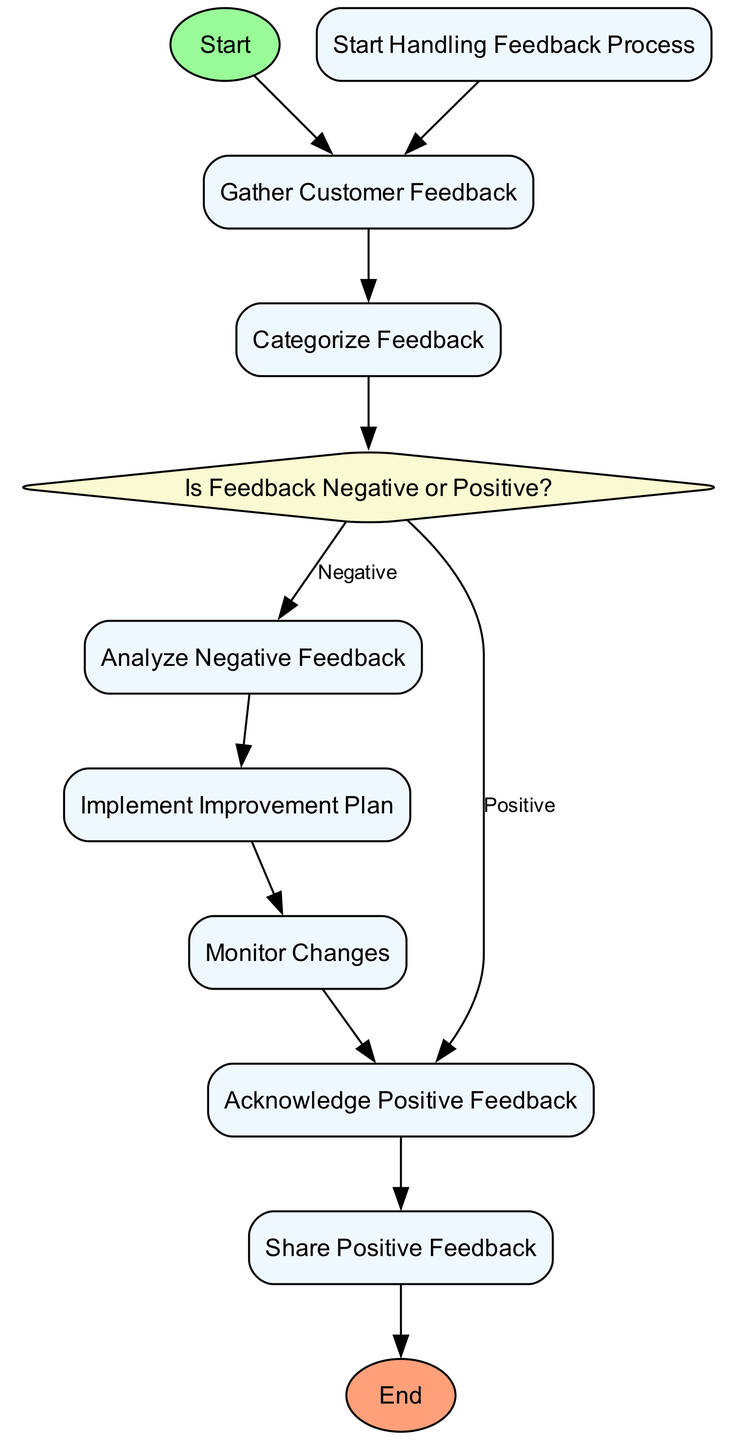What's the first action in the diagram? The first action after the start node is "Gather Customer Feedback", as it directly follows the start and represents the first step in the process.
Answer: Gather Customer Feedback How many types of nodes are present in the diagram? There are three types of nodes: start, action, decision, and end. The start and end nodes represent the boundaries of the process, while the action nodes perform tasks, and the decision node represents a point of evaluation.
Answer: Three What is the last action before the end node? The last action before reaching the end node is "Share Positive Feedback". This action is connected to the end node and represents the last step after managing positive feedback.
Answer: Share Positive Feedback What action follows negative feedback analysis? Following "Analyze Negative Feedback", the action that comes next is "Implement Improvement Plan", indicating that an improvement strategy is developed after analyzing the issues from negative feedback.
Answer: Implement Improvement Plan Which nodes are connected by the "Negative" edge from the decision node? The "Negative" edge connects the decision node "Is Feedback Negative or Positive?" to "Analyze Negative Feedback", leading to the analysis of issues identified in the negative feedback.
Answer: Analyze Negative Feedback How many actions are there in total within the diagram? There are six action nodes in the diagram: "Gather Customer Feedback", "Categorize Feedback", "Analyze Negative Feedback", "Implement Improvement Plan", "Acknowledge Positive Feedback", and "Share Positive Feedback".
Answer: Six What is the outcome if the feedback is positive? If feedback is positive, the process flows to "Acknowledge Positive Feedback", which involves sending thank-you messages or rewards to customers and enhances customer relations.
Answer: Acknowledge Positive Feedback What represents the end of the handling feedback process? The "End Handling Feedback Process" node represents the conclusion of the entire feedback handling process, indicating that all feedback has been processed.
Answer: End Handling Feedback Process What comes after monitoring changes? After "Monitor Changes", there is a connection to the end node "End Handling Feedback Process", indicating that monitoring marks the final stage in the feedback process.
Answer: End Handling Feedback Process 